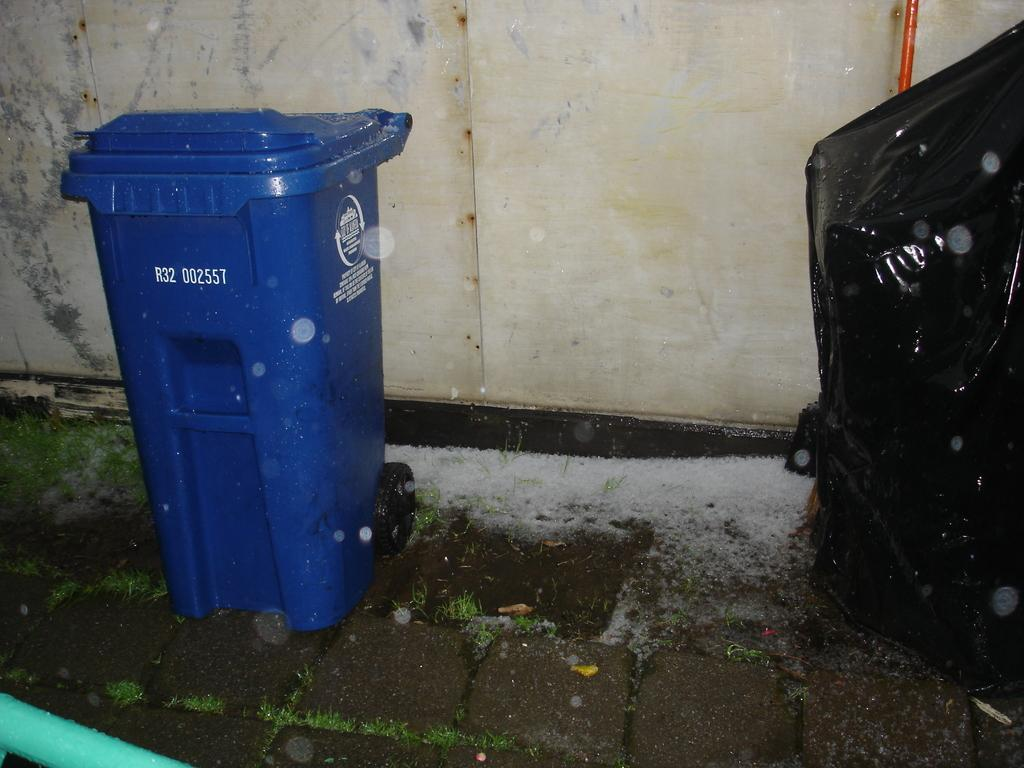<image>
Describe the image concisely. A blue recycling bin marked R32 002557 sits near a wall. 